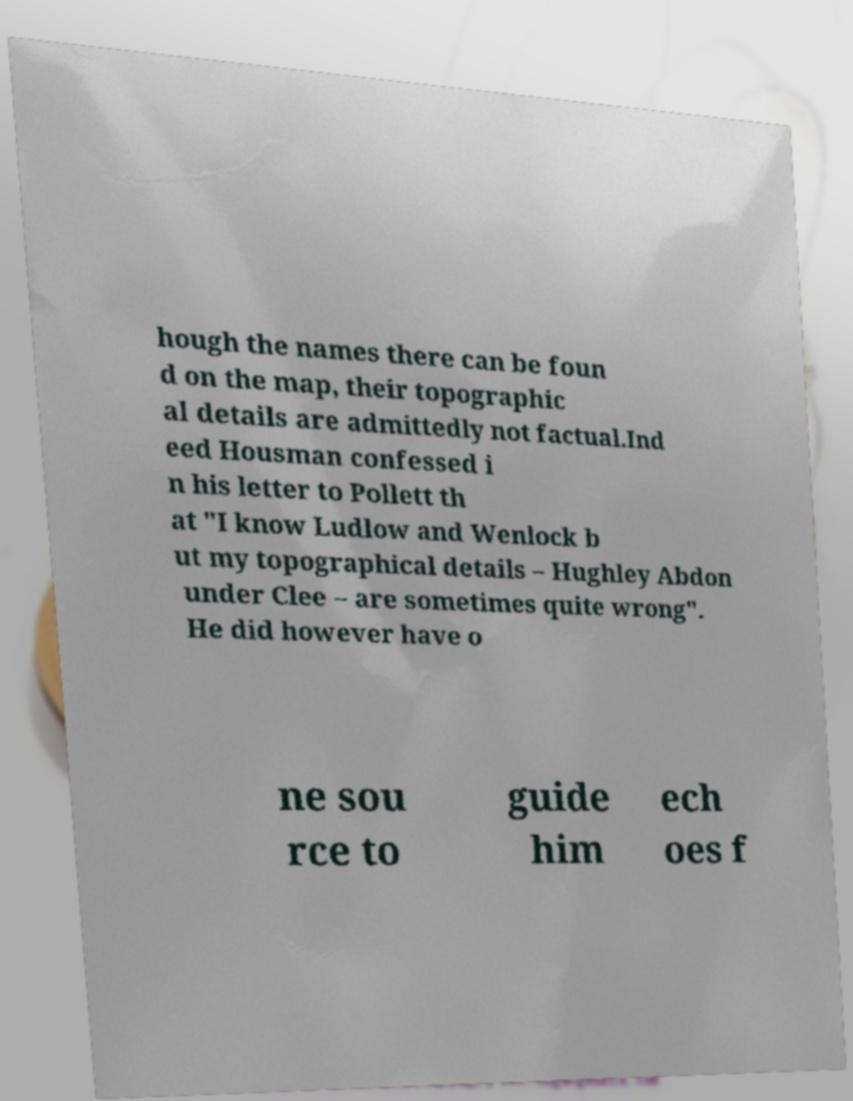For documentation purposes, I need the text within this image transcribed. Could you provide that? hough the names there can be foun d on the map, their topographic al details are admittedly not factual.Ind eed Housman confessed i n his letter to Pollett th at "I know Ludlow and Wenlock b ut my topographical details – Hughley Abdon under Clee – are sometimes quite wrong". He did however have o ne sou rce to guide him ech oes f 